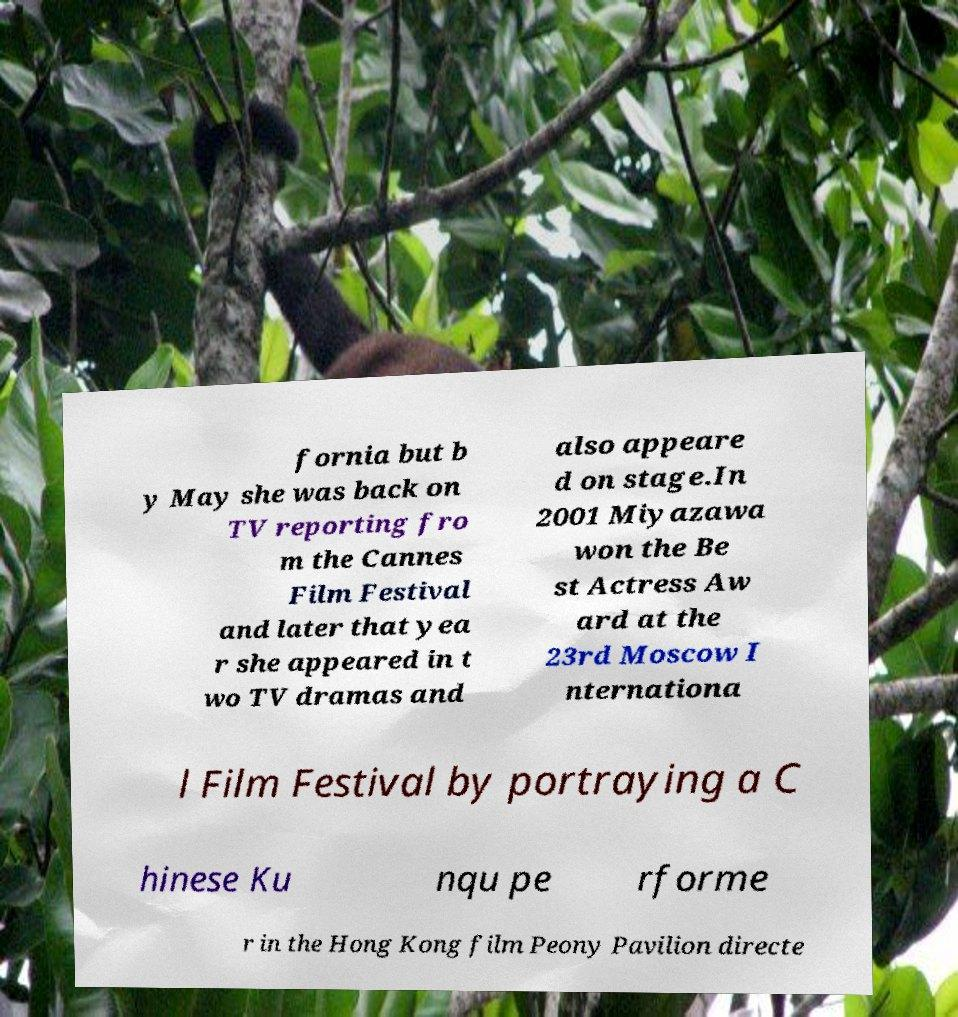Can you accurately transcribe the text from the provided image for me? fornia but b y May she was back on TV reporting fro m the Cannes Film Festival and later that yea r she appeared in t wo TV dramas and also appeare d on stage.In 2001 Miyazawa won the Be st Actress Aw ard at the 23rd Moscow I nternationa l Film Festival by portraying a C hinese Ku nqu pe rforme r in the Hong Kong film Peony Pavilion directe 